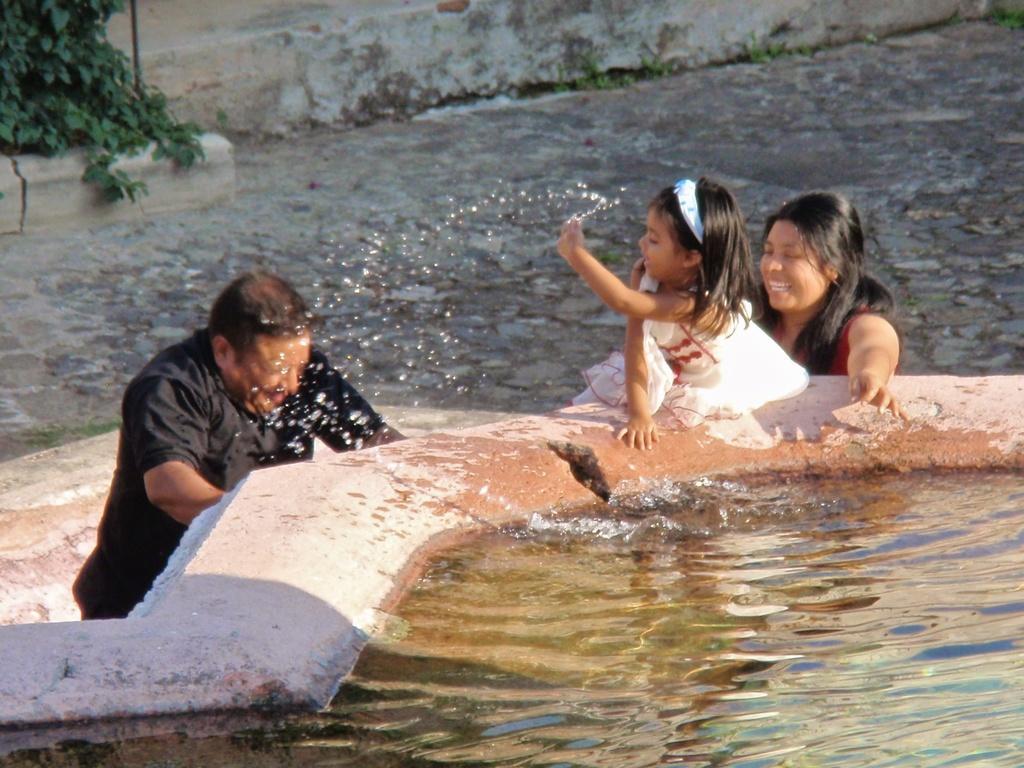How would you summarize this image in a sentence or two? In this image there are few people on the ground. They are playing with water. There is water around them. In the top left there are plants on the ground. 